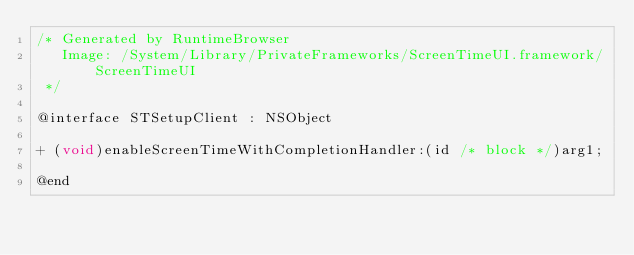<code> <loc_0><loc_0><loc_500><loc_500><_C_>/* Generated by RuntimeBrowser
   Image: /System/Library/PrivateFrameworks/ScreenTimeUI.framework/ScreenTimeUI
 */

@interface STSetupClient : NSObject

+ (void)enableScreenTimeWithCompletionHandler:(id /* block */)arg1;

@end
</code> 